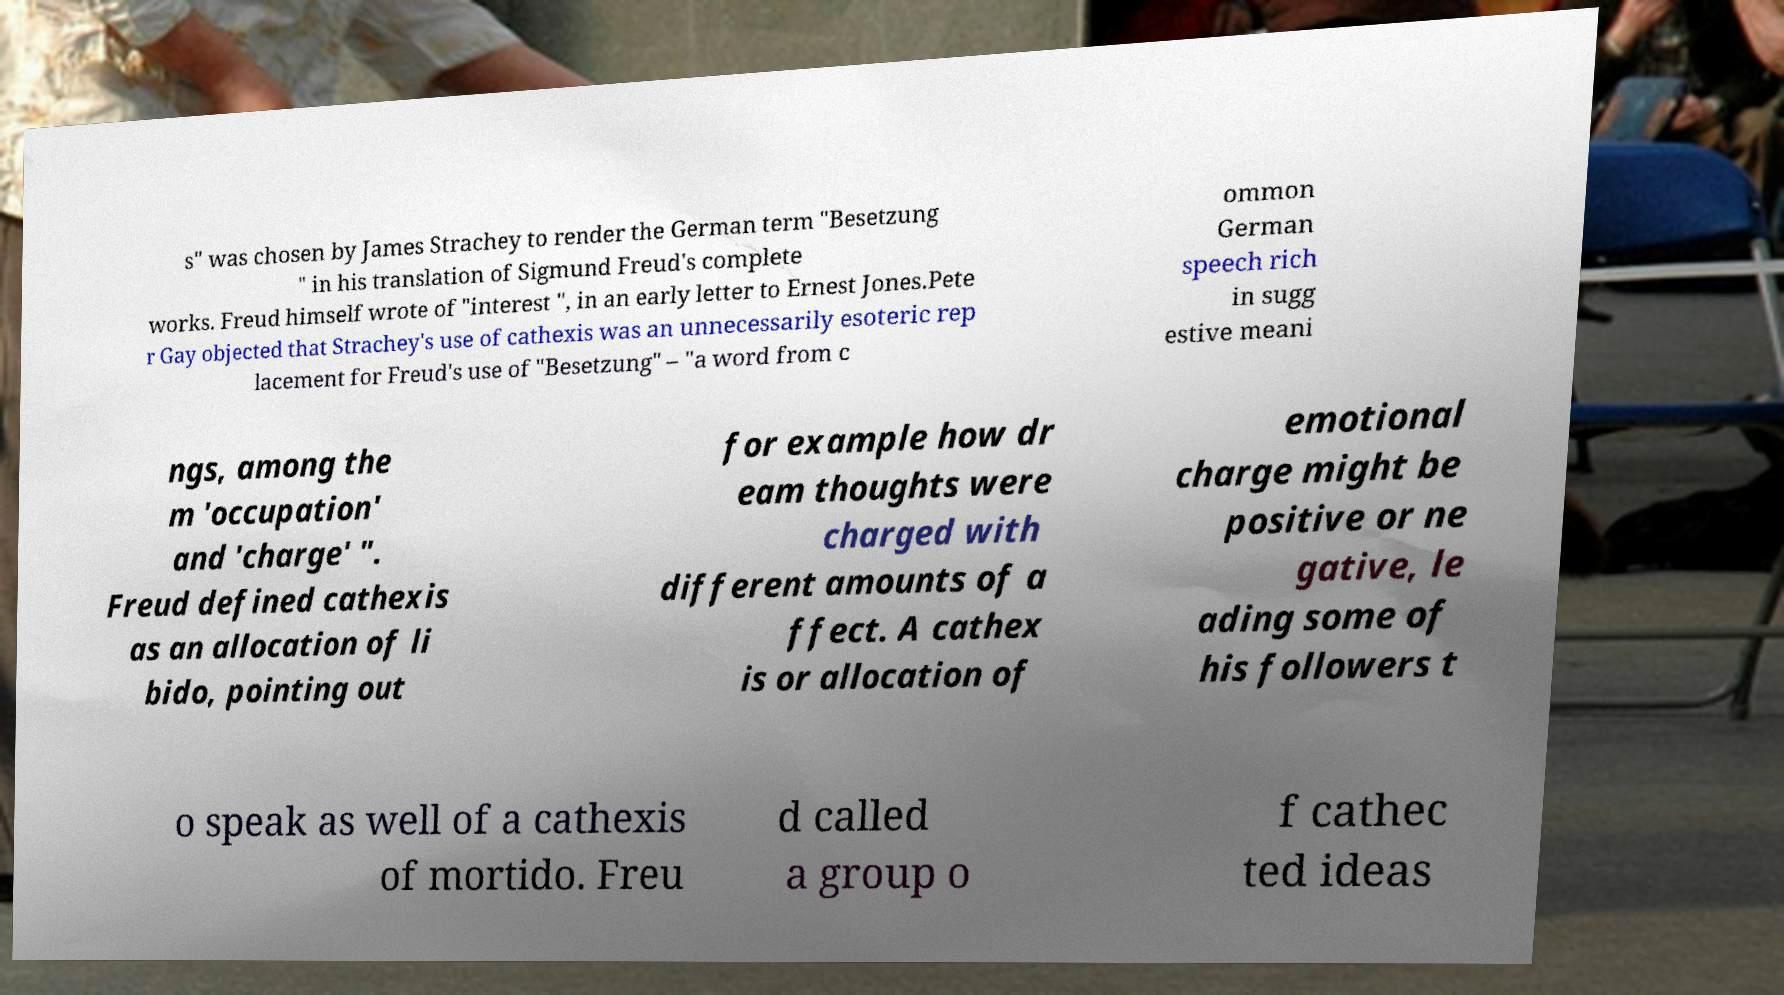There's text embedded in this image that I need extracted. Can you transcribe it verbatim? s" was chosen by James Strachey to render the German term "Besetzung " in his translation of Sigmund Freud's complete works. Freud himself wrote of "interest ", in an early letter to Ernest Jones.Pete r Gay objected that Strachey's use of cathexis was an unnecessarily esoteric rep lacement for Freud's use of "Besetzung" – "a word from c ommon German speech rich in sugg estive meani ngs, among the m 'occupation' and 'charge' ". Freud defined cathexis as an allocation of li bido, pointing out for example how dr eam thoughts were charged with different amounts of a ffect. A cathex is or allocation of emotional charge might be positive or ne gative, le ading some of his followers t o speak as well of a cathexis of mortido. Freu d called a group o f cathec ted ideas 